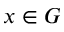Convert formula to latex. <formula><loc_0><loc_0><loc_500><loc_500>x \in G</formula> 